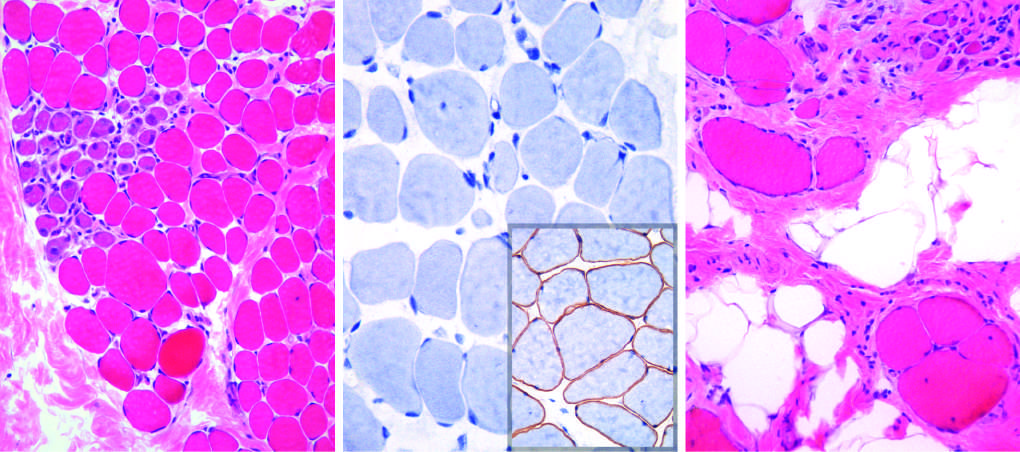what do myofibers show in size?
Answer the question using a single word or phrase. Variation 